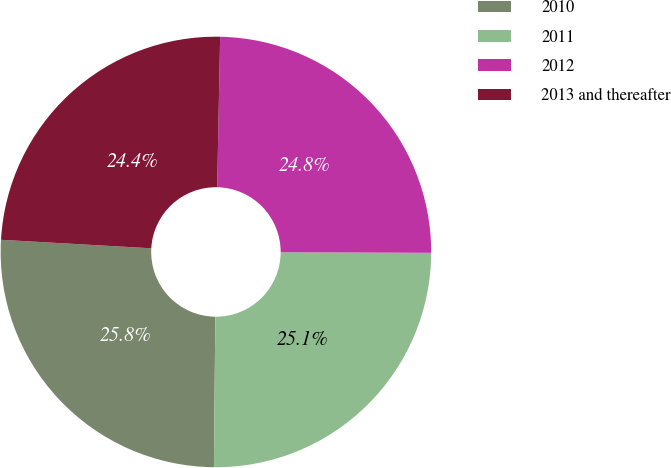<chart> <loc_0><loc_0><loc_500><loc_500><pie_chart><fcel>2010<fcel>2011<fcel>2012<fcel>2013 and thereafter<nl><fcel>25.75%<fcel>25.08%<fcel>24.75%<fcel>24.41%<nl></chart> 